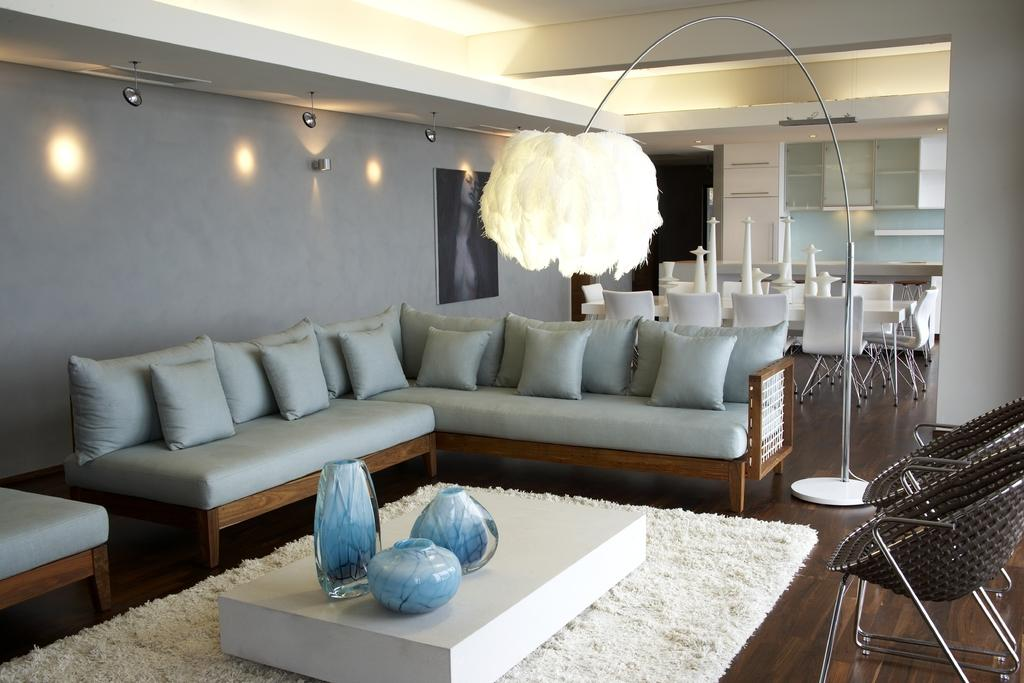What is located in the center of the image? There is a table and a carpet in the center of the image. What furniture is on the right side of the image? There are two chairs on the right side of the image. What can be seen in the background of the image? There is a wall, a light, a sofa with pillows, a photo frame, a table, and chairs in the background of the image. How many knots are tied in the carpet in the image? There is no information about knots in the carpet, as the focus is on the presence of the carpet and table in the center of the image. What number is written on the photo frame in the image? There is no information about any numbers written on the photo frame, as the focus is on the presence of the photo frame and other objects in the background of the image. 